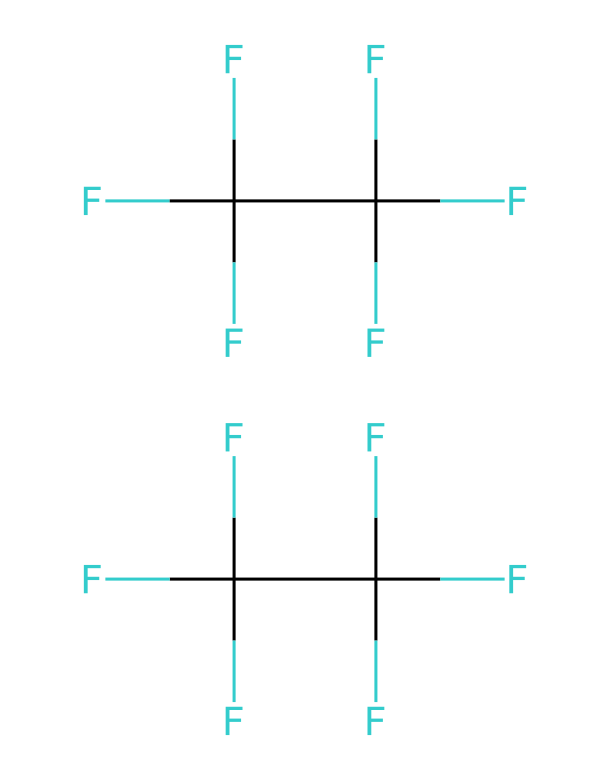What is the name of this refrigerant? The chemical represented by the SMILES notation is R-410A, which is a blend of two refrigerants, specifically composed of difluoromethane and pentafluoroethane.
Answer: R-410A How many carbon atoms are present in this molecule? Counting the carbon atoms in the SMILES representation, we can see there are two distinct groups of carbon atoms, and each group contains one carbon atom, leading to a total of two carbon atoms.
Answer: 2 What is the total number of fluorine atoms in this compound? Each of the carbon atoms in the chemical structure is bonded to several fluorine atoms. In total, there are six fluorine atoms around each carbon atom, leading to a total of twelve fluorine atoms in the chemical.
Answer: 12 What type of chemical bond is primarily present between the C and F atoms? The bonds between the carbon and fluorine atoms are predominantly covalent bonds, as they involve the sharing of electrons between these two nonmetals.
Answer: covalent Is R-410A considered a greenhouse gas? Yes, R-410A is classified as a greenhouse gas, as it has a significant global warming potential due to its ability to trap heat in the atmosphere.
Answer: yes How does the molecular structure of R-410A contribute to its efficiency as a refrigerant? The high number of fluorine atoms in R-410A provides effective heat absorption and transfer properties, making it efficient for use in air conditioning and refrigeration systems.
Answer: effective heat absorption What makes R-410A a preferable choice over older refrigerants like R-22? R-410A has a higher efficiency rating and lower ozone depletion potential when compared to R-22, making it a more environmentally friendly option for refrigeration.
Answer: higher efficiency and lower ozone depletion potential 